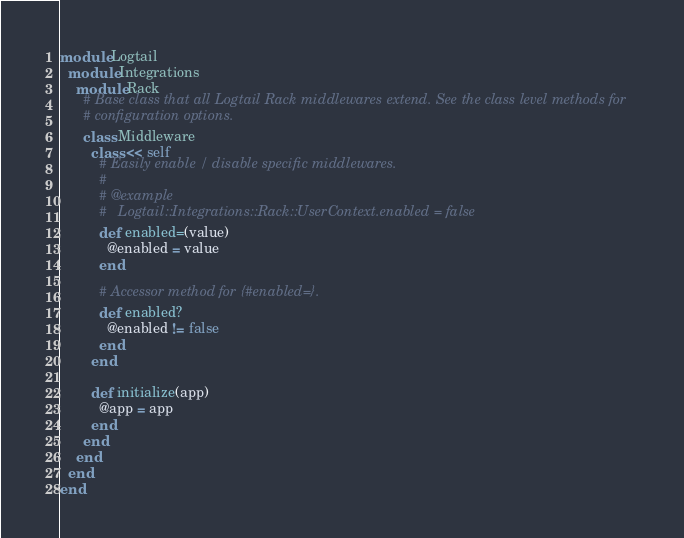<code> <loc_0><loc_0><loc_500><loc_500><_Ruby_>module Logtail
  module Integrations
    module Rack
      # Base class that all Logtail Rack middlewares extend. See the class level methods for
      # configuration options.
      class Middleware
        class << self
          # Easily enable / disable specific middlewares.
          #
          # @example
          #   Logtail::Integrations::Rack::UserContext.enabled = false
          def enabled=(value)
            @enabled = value
          end

          # Accessor method for {#enabled=}.
          def enabled?
            @enabled != false
          end
        end

        def initialize(app)
          @app = app
        end
      end
    end
  end
end
</code> 